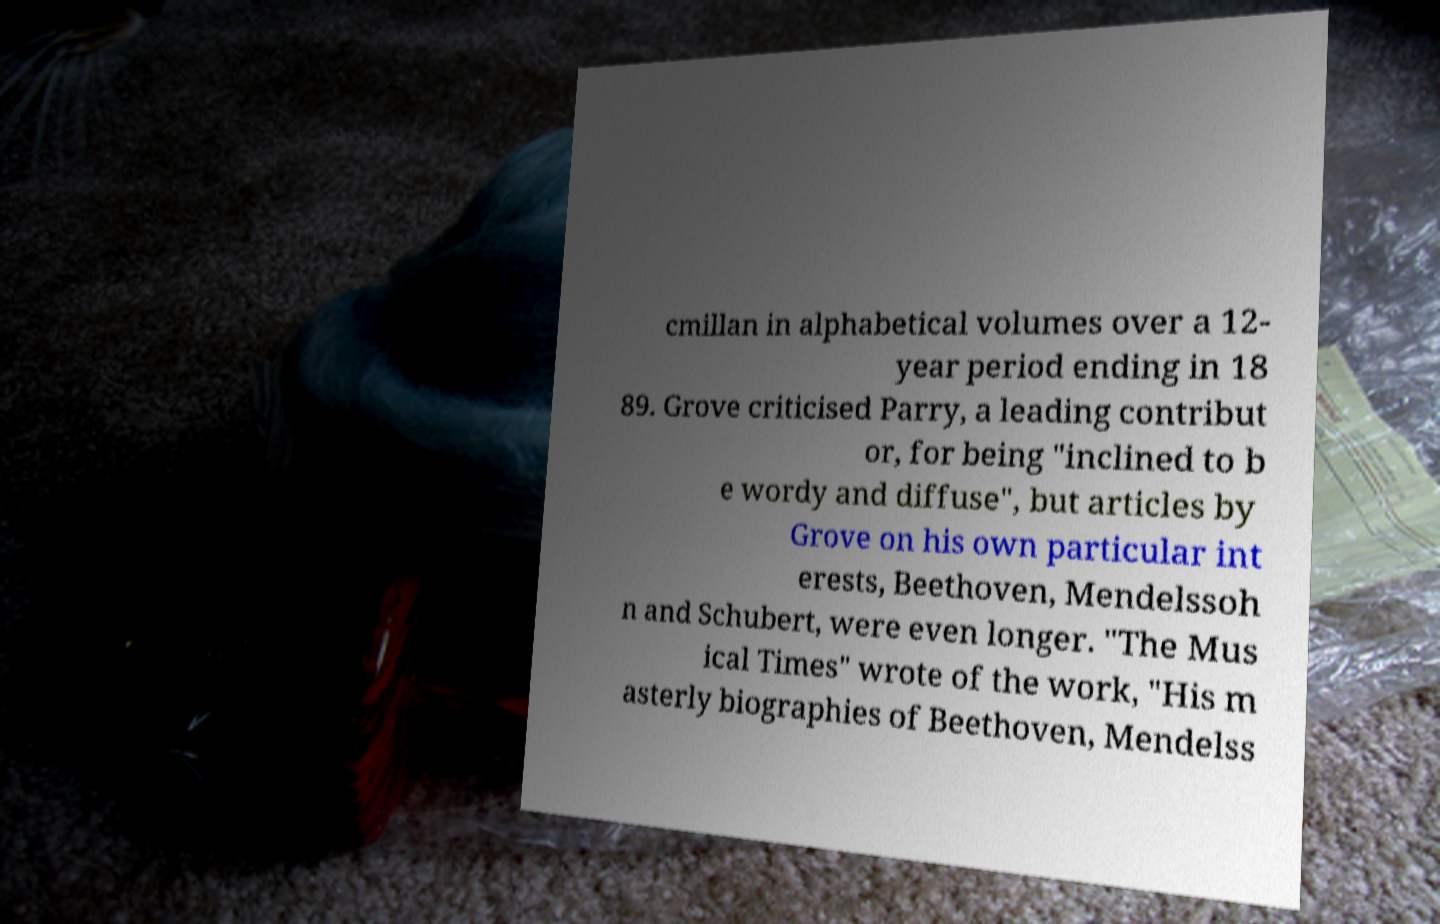Could you assist in decoding the text presented in this image and type it out clearly? cmillan in alphabetical volumes over a 12- year period ending in 18 89. Grove criticised Parry, a leading contribut or, for being "inclined to b e wordy and diffuse", but articles by Grove on his own particular int erests, Beethoven, Mendelssoh n and Schubert, were even longer. "The Mus ical Times" wrote of the work, "His m asterly biographies of Beethoven, Mendelss 